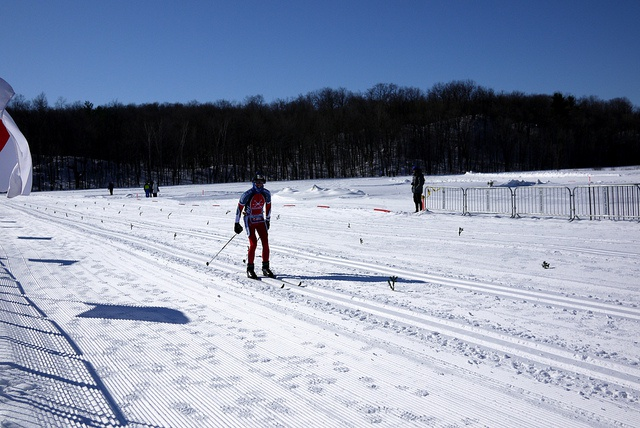Describe the objects in this image and their specific colors. I can see people in blue, black, maroon, navy, and gray tones, people in blue, black, and gray tones, skis in blue, lightgray, black, darkgray, and navy tones, people in blue, black, gray, and darkgray tones, and people in blue, black, darkgreen, navy, and darkblue tones in this image. 